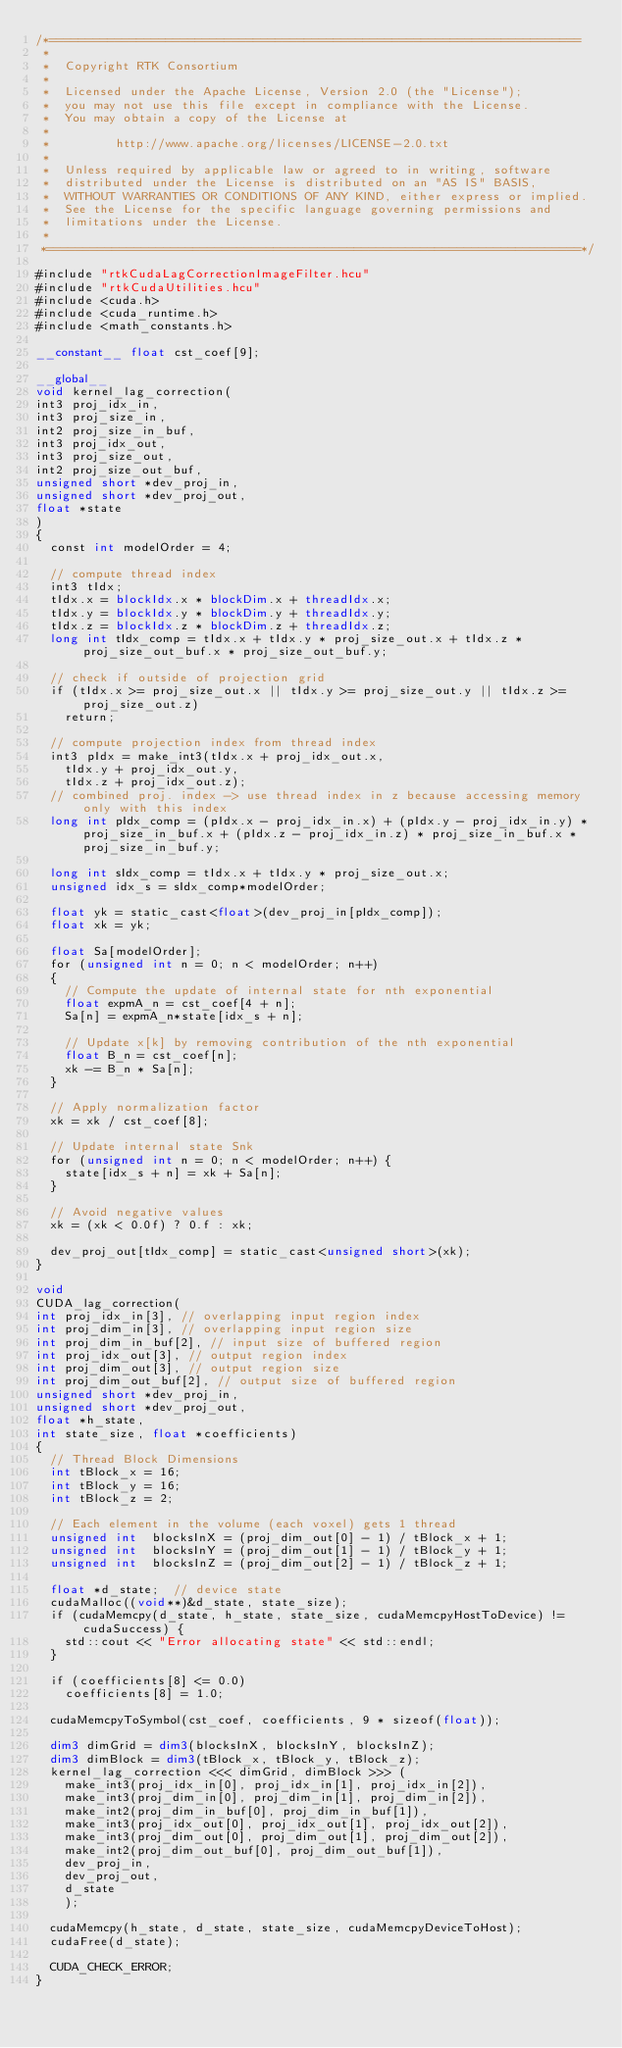Convert code to text. <code><loc_0><loc_0><loc_500><loc_500><_Cuda_>/*=========================================================================
 *
 *  Copyright RTK Consortium
 *
 *  Licensed under the Apache License, Version 2.0 (the "License");
 *  you may not use this file except in compliance with the License.
 *  You may obtain a copy of the License at
 *
 *         http://www.apache.org/licenses/LICENSE-2.0.txt
 *
 *  Unless required by applicable law or agreed to in writing, software
 *  distributed under the License is distributed on an "AS IS" BASIS,
 *  WITHOUT WARRANTIES OR CONDITIONS OF ANY KIND, either express or implied.
 *  See the License for the specific language governing permissions and
 *  limitations under the License.
 *
 *=========================================================================*/

#include "rtkCudaLagCorrectionImageFilter.hcu"
#include "rtkCudaUtilities.hcu"
#include <cuda.h>
#include <cuda_runtime.h>
#include <math_constants.h>

__constant__ float cst_coef[9];

__global__
void kernel_lag_correction(
int3 proj_idx_in,
int3 proj_size_in,
int2 proj_size_in_buf,
int3 proj_idx_out,
int3 proj_size_out,
int2 proj_size_out_buf,
unsigned short *dev_proj_in,
unsigned short *dev_proj_out,
float *state
)
{
  const int modelOrder = 4;

  // compute thread index
  int3 tIdx;
  tIdx.x = blockIdx.x * blockDim.x + threadIdx.x;
  tIdx.y = blockIdx.y * blockDim.y + threadIdx.y;
  tIdx.z = blockIdx.z * blockDim.z + threadIdx.z;
  long int tIdx_comp = tIdx.x + tIdx.y * proj_size_out.x + tIdx.z * proj_size_out_buf.x * proj_size_out_buf.y;

  // check if outside of projection grid
  if (tIdx.x >= proj_size_out.x || tIdx.y >= proj_size_out.y || tIdx.z >= proj_size_out.z)
    return;

  // compute projection index from thread index
  int3 pIdx = make_int3(tIdx.x + proj_idx_out.x,
    tIdx.y + proj_idx_out.y,
    tIdx.z + proj_idx_out.z);
  // combined proj. index -> use thread index in z because accessing memory only with this index
  long int pIdx_comp = (pIdx.x - proj_idx_in.x) + (pIdx.y - proj_idx_in.y) * proj_size_in_buf.x + (pIdx.z - proj_idx_in.z) * proj_size_in_buf.x * proj_size_in_buf.y;

  long int sIdx_comp = tIdx.x + tIdx.y * proj_size_out.x;
  unsigned idx_s = sIdx_comp*modelOrder;

  float yk = static_cast<float>(dev_proj_in[pIdx_comp]);
  float xk = yk;

  float Sa[modelOrder];
  for (unsigned int n = 0; n < modelOrder; n++)
  {
    // Compute the update of internal state for nth exponential
    float expmA_n = cst_coef[4 + n];
    Sa[n] = expmA_n*state[idx_s + n];

    // Update x[k] by removing contribution of the nth exponential
    float B_n = cst_coef[n];
    xk -= B_n * Sa[n];
  }

  // Apply normalization factor
  xk = xk / cst_coef[8];

  // Update internal state Snk
  for (unsigned int n = 0; n < modelOrder; n++) {
    state[idx_s + n] = xk + Sa[n];
  }

  // Avoid negative values
  xk = (xk < 0.0f) ? 0.f : xk;

  dev_proj_out[tIdx_comp] = static_cast<unsigned short>(xk);
}

void
CUDA_lag_correction(
int proj_idx_in[3], // overlapping input region index
int proj_dim_in[3], // overlapping input region size
int proj_dim_in_buf[2], // input size of buffered region
int proj_idx_out[3], // output region index
int proj_dim_out[3], // output region size
int proj_dim_out_buf[2], // output size of buffered region
unsigned short *dev_proj_in,
unsigned short *dev_proj_out,
float *h_state,
int state_size, float *coefficients)
{
  // Thread Block Dimensions
  int tBlock_x = 16;
  int tBlock_y = 16;
  int tBlock_z = 2;

  // Each element in the volume (each voxel) gets 1 thread
  unsigned int  blocksInX = (proj_dim_out[0] - 1) / tBlock_x + 1;
  unsigned int  blocksInY = (proj_dim_out[1] - 1) / tBlock_y + 1;
  unsigned int  blocksInZ = (proj_dim_out[2] - 1) / tBlock_z + 1;

  float *d_state;  // device state
  cudaMalloc((void**)&d_state, state_size);
  if (cudaMemcpy(d_state, h_state, state_size, cudaMemcpyHostToDevice) != cudaSuccess) {
    std::cout << "Error allocating state" << std::endl;
  }

  if (coefficients[8] <= 0.0)
    coefficients[8] = 1.0;

  cudaMemcpyToSymbol(cst_coef, coefficients, 9 * sizeof(float));

  dim3 dimGrid = dim3(blocksInX, blocksInY, blocksInZ);
  dim3 dimBlock = dim3(tBlock_x, tBlock_y, tBlock_z);
  kernel_lag_correction <<< dimGrid, dimBlock >>> (
    make_int3(proj_idx_in[0], proj_idx_in[1], proj_idx_in[2]),
    make_int3(proj_dim_in[0], proj_dim_in[1], proj_dim_in[2]),
    make_int2(proj_dim_in_buf[0], proj_dim_in_buf[1]),
    make_int3(proj_idx_out[0], proj_idx_out[1], proj_idx_out[2]),
    make_int3(proj_dim_out[0], proj_dim_out[1], proj_dim_out[2]),
    make_int2(proj_dim_out_buf[0], proj_dim_out_buf[1]),
    dev_proj_in,
    dev_proj_out,
    d_state
    );

  cudaMemcpy(h_state, d_state, state_size, cudaMemcpyDeviceToHost);
  cudaFree(d_state);

  CUDA_CHECK_ERROR;
}
</code> 